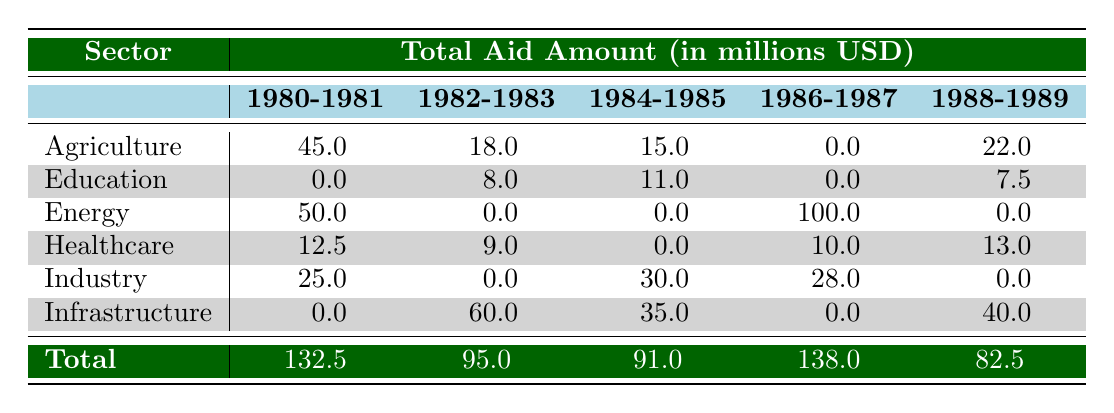What was the total aid amount for Agriculture in 1986-1987? Referring to the table, the total aid amount for Agriculture in the 1986-1987 period is 0.0 million USD.
Answer: 0.0 Which sector received the highest total aid amount during 1984-1985? Looking at the table, Infrastructure received a total aid amount of 35.0 million USD, which is the highest in that period, compared to the other sectors.
Answer: Infrastructure What is the combined total aid amount for Healthcare over the entire decade? Summing the amounts from the Healthcare sector across the years gives: 12.5 + 9.0 + 0.0 + 10.0 + 13.0 = 44.5 million USD.
Answer: 44.5 Did the Energy sector receive any aid in 1984-1985? By examining the table, the Energy sector shows an aid amount of 0.0 million USD for the 1984-1985 period, so the statement is false.
Answer: No What was the average aid amount for Industry from 1986 to 1989? The amounts for Industry in those years are 28.0 (1986) and 0.0 (1987 - 1989). The sum is 28.0 + 0.0 + 0.0 = 28.0, and then dividing by the number of periods (3) gives an average of 28.0 / 3 ≈ 9.33 million USD.
Answer: Approximately 9.33 Which sector had the lowest total aid amount in the entire 1980s? Adding up the totals for all sectors shows that Education had the lowest total aid amount of 26.5 million USD throughout the decade, based on the figures displayed in the table.
Answer: Education What was the difference in total aid amount between Agriculture and Infrastructure from 1982 to 1983? For Agriculture from 1982 to 1983, the total is 18.0 million USD, while for Infrastructure, it's 60.0 million USD. The difference is 60.0 - 18.0 = 42.0 million USD.
Answer: 42.0 